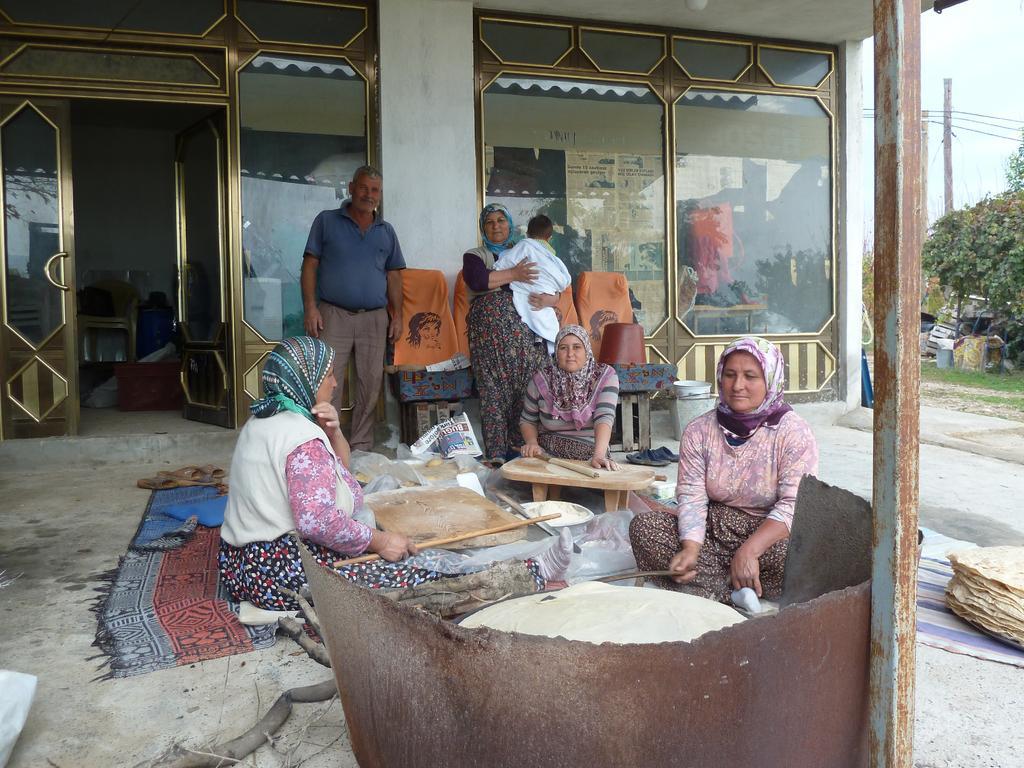Can you describe this image briefly? In this image three people are sitting and doing Roti and two people are standing. There are trees and grass. There is an electric pole. There is one open door on the left side. 